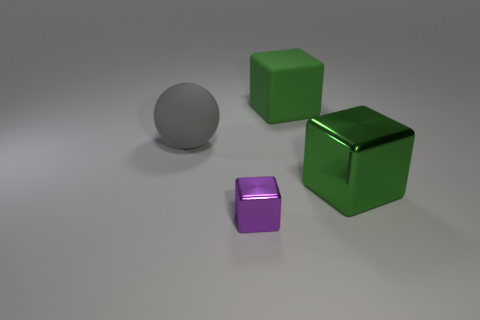Subtract all large green cubes. How many cubes are left? 1 Subtract all cyan spheres. How many green cubes are left? 2 Subtract 1 cubes. How many cubes are left? 2 Add 3 small cubes. How many objects exist? 7 Subtract all blue cubes. Subtract all cyan cylinders. How many cubes are left? 3 Subtract all blocks. How many objects are left? 1 Subtract all big green objects. Subtract all small purple cubes. How many objects are left? 1 Add 4 large rubber blocks. How many large rubber blocks are left? 5 Add 3 big gray matte blocks. How many big gray matte blocks exist? 3 Subtract 0 green balls. How many objects are left? 4 